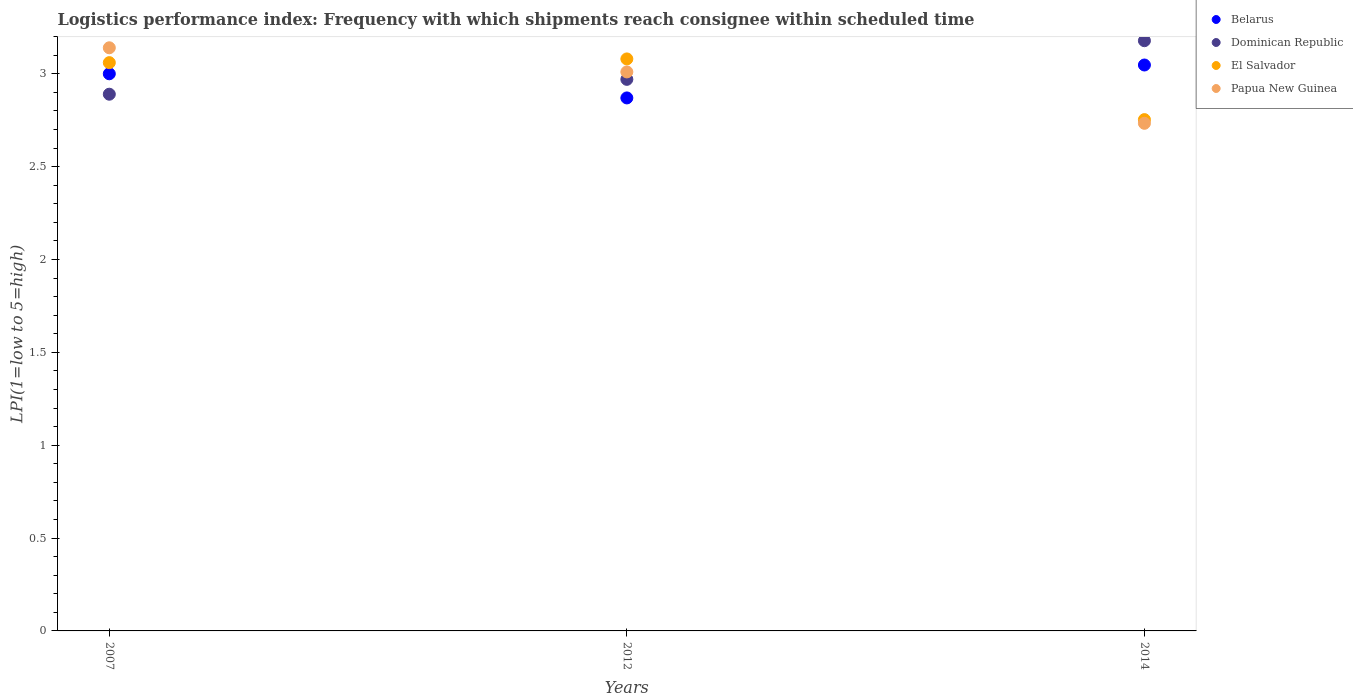How many different coloured dotlines are there?
Keep it short and to the point. 4. What is the logistics performance index in El Salvador in 2012?
Ensure brevity in your answer.  3.08. Across all years, what is the maximum logistics performance index in El Salvador?
Ensure brevity in your answer.  3.08. Across all years, what is the minimum logistics performance index in El Salvador?
Offer a very short reply. 2.75. What is the total logistics performance index in Papua New Guinea in the graph?
Keep it short and to the point. 8.88. What is the difference between the logistics performance index in Papua New Guinea in 2007 and that in 2012?
Make the answer very short. 0.13. What is the difference between the logistics performance index in El Salvador in 2014 and the logistics performance index in Dominican Republic in 2007?
Provide a short and direct response. -0.14. What is the average logistics performance index in Papua New Guinea per year?
Your answer should be compact. 2.96. In the year 2014, what is the difference between the logistics performance index in Dominican Republic and logistics performance index in Papua New Guinea?
Keep it short and to the point. 0.44. What is the ratio of the logistics performance index in El Salvador in 2007 to that in 2012?
Provide a short and direct response. 0.99. Is the difference between the logistics performance index in Dominican Republic in 2012 and 2014 greater than the difference between the logistics performance index in Papua New Guinea in 2012 and 2014?
Keep it short and to the point. No. What is the difference between the highest and the second highest logistics performance index in El Salvador?
Provide a short and direct response. 0.02. What is the difference between the highest and the lowest logistics performance index in Dominican Republic?
Keep it short and to the point. 0.29. Is it the case that in every year, the sum of the logistics performance index in El Salvador and logistics performance index in Dominican Republic  is greater than the logistics performance index in Papua New Guinea?
Offer a very short reply. Yes. Does the logistics performance index in El Salvador monotonically increase over the years?
Keep it short and to the point. No. Is the logistics performance index in Dominican Republic strictly greater than the logistics performance index in El Salvador over the years?
Provide a succinct answer. No. Is the logistics performance index in Dominican Republic strictly less than the logistics performance index in Papua New Guinea over the years?
Your answer should be very brief. No. How many dotlines are there?
Give a very brief answer. 4. Does the graph contain any zero values?
Ensure brevity in your answer.  No. Where does the legend appear in the graph?
Your response must be concise. Top right. How many legend labels are there?
Your response must be concise. 4. What is the title of the graph?
Offer a terse response. Logistics performance index: Frequency with which shipments reach consignee within scheduled time. Does "Europe(all income levels)" appear as one of the legend labels in the graph?
Your response must be concise. No. What is the label or title of the Y-axis?
Ensure brevity in your answer.  LPI(1=low to 5=high). What is the LPI(1=low to 5=high) of Belarus in 2007?
Your answer should be very brief. 3. What is the LPI(1=low to 5=high) of Dominican Republic in 2007?
Make the answer very short. 2.89. What is the LPI(1=low to 5=high) in El Salvador in 2007?
Your answer should be very brief. 3.06. What is the LPI(1=low to 5=high) in Papua New Guinea in 2007?
Ensure brevity in your answer.  3.14. What is the LPI(1=low to 5=high) in Belarus in 2012?
Offer a very short reply. 2.87. What is the LPI(1=low to 5=high) of Dominican Republic in 2012?
Ensure brevity in your answer.  2.97. What is the LPI(1=low to 5=high) in El Salvador in 2012?
Give a very brief answer. 3.08. What is the LPI(1=low to 5=high) of Papua New Guinea in 2012?
Your answer should be compact. 3.01. What is the LPI(1=low to 5=high) of Belarus in 2014?
Ensure brevity in your answer.  3.05. What is the LPI(1=low to 5=high) of Dominican Republic in 2014?
Provide a succinct answer. 3.18. What is the LPI(1=low to 5=high) in El Salvador in 2014?
Provide a succinct answer. 2.75. What is the LPI(1=low to 5=high) in Papua New Guinea in 2014?
Give a very brief answer. 2.73. Across all years, what is the maximum LPI(1=low to 5=high) of Belarus?
Offer a terse response. 3.05. Across all years, what is the maximum LPI(1=low to 5=high) of Dominican Republic?
Ensure brevity in your answer.  3.18. Across all years, what is the maximum LPI(1=low to 5=high) in El Salvador?
Your answer should be very brief. 3.08. Across all years, what is the maximum LPI(1=low to 5=high) of Papua New Guinea?
Your answer should be compact. 3.14. Across all years, what is the minimum LPI(1=low to 5=high) of Belarus?
Offer a very short reply. 2.87. Across all years, what is the minimum LPI(1=low to 5=high) in Dominican Republic?
Keep it short and to the point. 2.89. Across all years, what is the minimum LPI(1=low to 5=high) in El Salvador?
Give a very brief answer. 2.75. Across all years, what is the minimum LPI(1=low to 5=high) in Papua New Guinea?
Offer a terse response. 2.73. What is the total LPI(1=low to 5=high) of Belarus in the graph?
Give a very brief answer. 8.92. What is the total LPI(1=low to 5=high) of Dominican Republic in the graph?
Your answer should be very brief. 9.04. What is the total LPI(1=low to 5=high) in El Salvador in the graph?
Your answer should be very brief. 8.89. What is the total LPI(1=low to 5=high) of Papua New Guinea in the graph?
Keep it short and to the point. 8.88. What is the difference between the LPI(1=low to 5=high) in Belarus in 2007 and that in 2012?
Make the answer very short. 0.13. What is the difference between the LPI(1=low to 5=high) of Dominican Republic in 2007 and that in 2012?
Offer a terse response. -0.08. What is the difference between the LPI(1=low to 5=high) in El Salvador in 2007 and that in 2012?
Your answer should be compact. -0.02. What is the difference between the LPI(1=low to 5=high) of Papua New Guinea in 2007 and that in 2012?
Give a very brief answer. 0.13. What is the difference between the LPI(1=low to 5=high) in Belarus in 2007 and that in 2014?
Give a very brief answer. -0.05. What is the difference between the LPI(1=low to 5=high) in Dominican Republic in 2007 and that in 2014?
Make the answer very short. -0.29. What is the difference between the LPI(1=low to 5=high) in El Salvador in 2007 and that in 2014?
Your answer should be very brief. 0.31. What is the difference between the LPI(1=low to 5=high) in Papua New Guinea in 2007 and that in 2014?
Provide a succinct answer. 0.41. What is the difference between the LPI(1=low to 5=high) of Belarus in 2012 and that in 2014?
Your response must be concise. -0.18. What is the difference between the LPI(1=low to 5=high) in Dominican Republic in 2012 and that in 2014?
Give a very brief answer. -0.21. What is the difference between the LPI(1=low to 5=high) in El Salvador in 2012 and that in 2014?
Offer a very short reply. 0.33. What is the difference between the LPI(1=low to 5=high) of Papua New Guinea in 2012 and that in 2014?
Provide a short and direct response. 0.28. What is the difference between the LPI(1=low to 5=high) in Belarus in 2007 and the LPI(1=low to 5=high) in Dominican Republic in 2012?
Your answer should be compact. 0.03. What is the difference between the LPI(1=low to 5=high) of Belarus in 2007 and the LPI(1=low to 5=high) of El Salvador in 2012?
Provide a short and direct response. -0.08. What is the difference between the LPI(1=low to 5=high) in Belarus in 2007 and the LPI(1=low to 5=high) in Papua New Guinea in 2012?
Your answer should be very brief. -0.01. What is the difference between the LPI(1=low to 5=high) of Dominican Republic in 2007 and the LPI(1=low to 5=high) of El Salvador in 2012?
Offer a terse response. -0.19. What is the difference between the LPI(1=low to 5=high) in Dominican Republic in 2007 and the LPI(1=low to 5=high) in Papua New Guinea in 2012?
Make the answer very short. -0.12. What is the difference between the LPI(1=low to 5=high) of Belarus in 2007 and the LPI(1=low to 5=high) of Dominican Republic in 2014?
Provide a short and direct response. -0.18. What is the difference between the LPI(1=low to 5=high) in Belarus in 2007 and the LPI(1=low to 5=high) in El Salvador in 2014?
Your answer should be compact. 0.25. What is the difference between the LPI(1=low to 5=high) of Belarus in 2007 and the LPI(1=low to 5=high) of Papua New Guinea in 2014?
Your answer should be very brief. 0.27. What is the difference between the LPI(1=low to 5=high) of Dominican Republic in 2007 and the LPI(1=low to 5=high) of El Salvador in 2014?
Give a very brief answer. 0.14. What is the difference between the LPI(1=low to 5=high) of Dominican Republic in 2007 and the LPI(1=low to 5=high) of Papua New Guinea in 2014?
Ensure brevity in your answer.  0.16. What is the difference between the LPI(1=low to 5=high) in El Salvador in 2007 and the LPI(1=low to 5=high) in Papua New Guinea in 2014?
Offer a terse response. 0.33. What is the difference between the LPI(1=low to 5=high) of Belarus in 2012 and the LPI(1=low to 5=high) of Dominican Republic in 2014?
Your answer should be compact. -0.31. What is the difference between the LPI(1=low to 5=high) of Belarus in 2012 and the LPI(1=low to 5=high) of El Salvador in 2014?
Your response must be concise. 0.12. What is the difference between the LPI(1=low to 5=high) of Belarus in 2012 and the LPI(1=low to 5=high) of Papua New Guinea in 2014?
Your answer should be very brief. 0.14. What is the difference between the LPI(1=low to 5=high) of Dominican Republic in 2012 and the LPI(1=low to 5=high) of El Salvador in 2014?
Your response must be concise. 0.22. What is the difference between the LPI(1=low to 5=high) of Dominican Republic in 2012 and the LPI(1=low to 5=high) of Papua New Guinea in 2014?
Your answer should be compact. 0.24. What is the difference between the LPI(1=low to 5=high) of El Salvador in 2012 and the LPI(1=low to 5=high) of Papua New Guinea in 2014?
Ensure brevity in your answer.  0.35. What is the average LPI(1=low to 5=high) of Belarus per year?
Your response must be concise. 2.97. What is the average LPI(1=low to 5=high) in Dominican Republic per year?
Keep it short and to the point. 3.01. What is the average LPI(1=low to 5=high) in El Salvador per year?
Your response must be concise. 2.96. What is the average LPI(1=low to 5=high) in Papua New Guinea per year?
Offer a terse response. 2.96. In the year 2007, what is the difference between the LPI(1=low to 5=high) of Belarus and LPI(1=low to 5=high) of Dominican Republic?
Your response must be concise. 0.11. In the year 2007, what is the difference between the LPI(1=low to 5=high) in Belarus and LPI(1=low to 5=high) in El Salvador?
Your response must be concise. -0.06. In the year 2007, what is the difference between the LPI(1=low to 5=high) in Belarus and LPI(1=low to 5=high) in Papua New Guinea?
Offer a terse response. -0.14. In the year 2007, what is the difference between the LPI(1=low to 5=high) in Dominican Republic and LPI(1=low to 5=high) in El Salvador?
Offer a very short reply. -0.17. In the year 2007, what is the difference between the LPI(1=low to 5=high) of El Salvador and LPI(1=low to 5=high) of Papua New Guinea?
Keep it short and to the point. -0.08. In the year 2012, what is the difference between the LPI(1=low to 5=high) in Belarus and LPI(1=low to 5=high) in El Salvador?
Provide a short and direct response. -0.21. In the year 2012, what is the difference between the LPI(1=low to 5=high) in Belarus and LPI(1=low to 5=high) in Papua New Guinea?
Your answer should be very brief. -0.14. In the year 2012, what is the difference between the LPI(1=low to 5=high) of Dominican Republic and LPI(1=low to 5=high) of El Salvador?
Make the answer very short. -0.11. In the year 2012, what is the difference between the LPI(1=low to 5=high) in Dominican Republic and LPI(1=low to 5=high) in Papua New Guinea?
Your response must be concise. -0.04. In the year 2012, what is the difference between the LPI(1=low to 5=high) of El Salvador and LPI(1=low to 5=high) of Papua New Guinea?
Give a very brief answer. 0.07. In the year 2014, what is the difference between the LPI(1=low to 5=high) of Belarus and LPI(1=low to 5=high) of Dominican Republic?
Make the answer very short. -0.13. In the year 2014, what is the difference between the LPI(1=low to 5=high) of Belarus and LPI(1=low to 5=high) of El Salvador?
Offer a terse response. 0.29. In the year 2014, what is the difference between the LPI(1=low to 5=high) in Belarus and LPI(1=low to 5=high) in Papua New Guinea?
Your answer should be compact. 0.31. In the year 2014, what is the difference between the LPI(1=low to 5=high) in Dominican Republic and LPI(1=low to 5=high) in El Salvador?
Offer a very short reply. 0.42. In the year 2014, what is the difference between the LPI(1=low to 5=high) of Dominican Republic and LPI(1=low to 5=high) of Papua New Guinea?
Give a very brief answer. 0.44. In the year 2014, what is the difference between the LPI(1=low to 5=high) in El Salvador and LPI(1=low to 5=high) in Papua New Guinea?
Ensure brevity in your answer.  0.02. What is the ratio of the LPI(1=low to 5=high) in Belarus in 2007 to that in 2012?
Your answer should be compact. 1.05. What is the ratio of the LPI(1=low to 5=high) in Dominican Republic in 2007 to that in 2012?
Ensure brevity in your answer.  0.97. What is the ratio of the LPI(1=low to 5=high) of El Salvador in 2007 to that in 2012?
Your answer should be very brief. 0.99. What is the ratio of the LPI(1=low to 5=high) in Papua New Guinea in 2007 to that in 2012?
Give a very brief answer. 1.04. What is the ratio of the LPI(1=low to 5=high) in Belarus in 2007 to that in 2014?
Offer a terse response. 0.98. What is the ratio of the LPI(1=low to 5=high) in Dominican Republic in 2007 to that in 2014?
Your answer should be very brief. 0.91. What is the ratio of the LPI(1=low to 5=high) in El Salvador in 2007 to that in 2014?
Provide a succinct answer. 1.11. What is the ratio of the LPI(1=low to 5=high) of Papua New Guinea in 2007 to that in 2014?
Offer a very short reply. 1.15. What is the ratio of the LPI(1=low to 5=high) of Belarus in 2012 to that in 2014?
Keep it short and to the point. 0.94. What is the ratio of the LPI(1=low to 5=high) of Dominican Republic in 2012 to that in 2014?
Ensure brevity in your answer.  0.93. What is the ratio of the LPI(1=low to 5=high) in El Salvador in 2012 to that in 2014?
Your answer should be very brief. 1.12. What is the ratio of the LPI(1=low to 5=high) of Papua New Guinea in 2012 to that in 2014?
Provide a succinct answer. 1.1. What is the difference between the highest and the second highest LPI(1=low to 5=high) in Belarus?
Offer a terse response. 0.05. What is the difference between the highest and the second highest LPI(1=low to 5=high) of Dominican Republic?
Your response must be concise. 0.21. What is the difference between the highest and the second highest LPI(1=low to 5=high) of Papua New Guinea?
Provide a short and direct response. 0.13. What is the difference between the highest and the lowest LPI(1=low to 5=high) in Belarus?
Make the answer very short. 0.18. What is the difference between the highest and the lowest LPI(1=low to 5=high) in Dominican Republic?
Your answer should be compact. 0.29. What is the difference between the highest and the lowest LPI(1=low to 5=high) of El Salvador?
Keep it short and to the point. 0.33. What is the difference between the highest and the lowest LPI(1=low to 5=high) of Papua New Guinea?
Give a very brief answer. 0.41. 